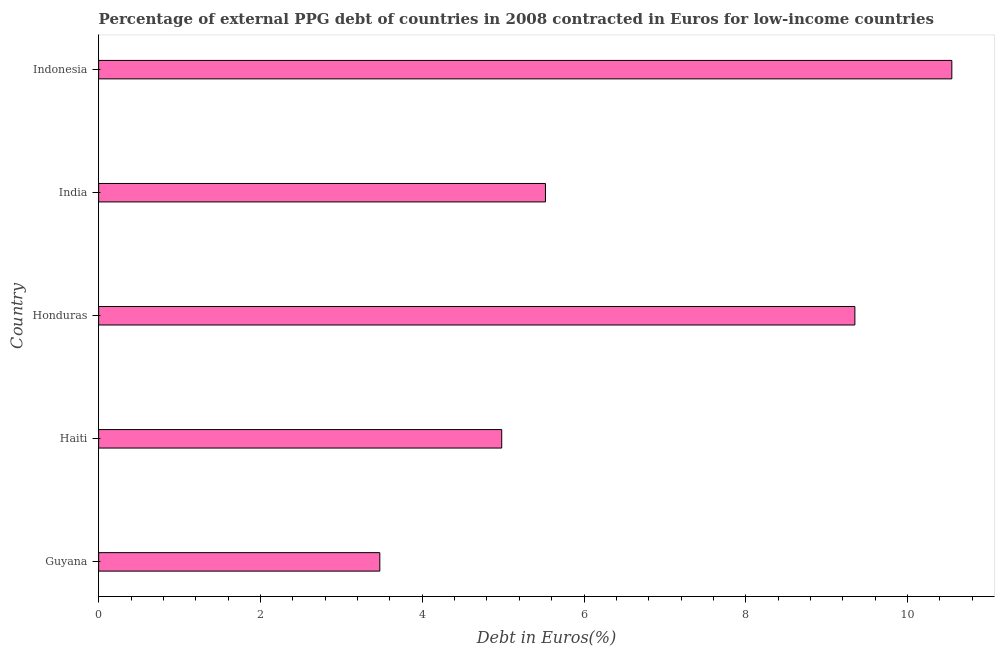Does the graph contain grids?
Provide a short and direct response. No. What is the title of the graph?
Your answer should be very brief. Percentage of external PPG debt of countries in 2008 contracted in Euros for low-income countries. What is the label or title of the X-axis?
Your answer should be very brief. Debt in Euros(%). What is the label or title of the Y-axis?
Provide a short and direct response. Country. What is the currency composition of ppg debt in India?
Keep it short and to the point. 5.52. Across all countries, what is the maximum currency composition of ppg debt?
Give a very brief answer. 10.55. Across all countries, what is the minimum currency composition of ppg debt?
Your answer should be very brief. 3.48. In which country was the currency composition of ppg debt minimum?
Provide a succinct answer. Guyana. What is the sum of the currency composition of ppg debt?
Give a very brief answer. 33.88. What is the difference between the currency composition of ppg debt in Guyana and India?
Provide a succinct answer. -2.05. What is the average currency composition of ppg debt per country?
Offer a terse response. 6.78. What is the median currency composition of ppg debt?
Your answer should be very brief. 5.52. What is the ratio of the currency composition of ppg debt in Haiti to that in Indonesia?
Give a very brief answer. 0.47. What is the difference between the highest and the second highest currency composition of ppg debt?
Your answer should be very brief. 1.2. What is the difference between the highest and the lowest currency composition of ppg debt?
Offer a terse response. 7.07. In how many countries, is the currency composition of ppg debt greater than the average currency composition of ppg debt taken over all countries?
Keep it short and to the point. 2. Are all the bars in the graph horizontal?
Provide a succinct answer. Yes. How many countries are there in the graph?
Your response must be concise. 5. What is the Debt in Euros(%) in Guyana?
Your answer should be compact. 3.48. What is the Debt in Euros(%) in Haiti?
Provide a succinct answer. 4.98. What is the Debt in Euros(%) of Honduras?
Ensure brevity in your answer.  9.35. What is the Debt in Euros(%) in India?
Provide a short and direct response. 5.52. What is the Debt in Euros(%) of Indonesia?
Your answer should be compact. 10.55. What is the difference between the Debt in Euros(%) in Guyana and Haiti?
Ensure brevity in your answer.  -1.51. What is the difference between the Debt in Euros(%) in Guyana and Honduras?
Make the answer very short. -5.87. What is the difference between the Debt in Euros(%) in Guyana and India?
Keep it short and to the point. -2.05. What is the difference between the Debt in Euros(%) in Guyana and Indonesia?
Your answer should be compact. -7.07. What is the difference between the Debt in Euros(%) in Haiti and Honduras?
Offer a very short reply. -4.37. What is the difference between the Debt in Euros(%) in Haiti and India?
Offer a very short reply. -0.54. What is the difference between the Debt in Euros(%) in Haiti and Indonesia?
Your answer should be compact. -5.56. What is the difference between the Debt in Euros(%) in Honduras and India?
Give a very brief answer. 3.82. What is the difference between the Debt in Euros(%) in Honduras and Indonesia?
Keep it short and to the point. -1.2. What is the difference between the Debt in Euros(%) in India and Indonesia?
Your answer should be very brief. -5.02. What is the ratio of the Debt in Euros(%) in Guyana to that in Haiti?
Your answer should be very brief. 0.7. What is the ratio of the Debt in Euros(%) in Guyana to that in Honduras?
Your answer should be very brief. 0.37. What is the ratio of the Debt in Euros(%) in Guyana to that in India?
Make the answer very short. 0.63. What is the ratio of the Debt in Euros(%) in Guyana to that in Indonesia?
Ensure brevity in your answer.  0.33. What is the ratio of the Debt in Euros(%) in Haiti to that in Honduras?
Keep it short and to the point. 0.53. What is the ratio of the Debt in Euros(%) in Haiti to that in India?
Your answer should be very brief. 0.9. What is the ratio of the Debt in Euros(%) in Haiti to that in Indonesia?
Ensure brevity in your answer.  0.47. What is the ratio of the Debt in Euros(%) in Honduras to that in India?
Offer a terse response. 1.69. What is the ratio of the Debt in Euros(%) in Honduras to that in Indonesia?
Give a very brief answer. 0.89. What is the ratio of the Debt in Euros(%) in India to that in Indonesia?
Provide a succinct answer. 0.52. 